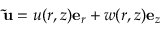Convert formula to latex. <formula><loc_0><loc_0><loc_500><loc_500>\tilde { u } = u ( r , z ) e _ { r } + w ( r , z ) e _ { z }</formula> 